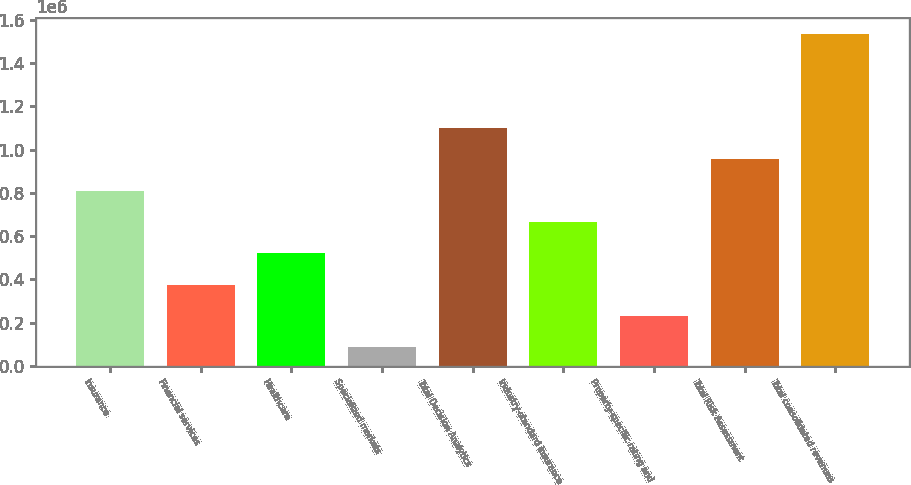Convert chart to OTSL. <chart><loc_0><loc_0><loc_500><loc_500><bar_chart><fcel>Insurance<fcel>Financial services<fcel>Healthcare<fcel>Specialized markets<fcel>Total Decision Analytics<fcel>Industry-standard insurance<fcel>Property-specific rating and<fcel>Total Risk Assessment<fcel>Total consolidated revenues<nl><fcel>809842<fcel>375155<fcel>520051<fcel>85364<fcel>1.09963e+06<fcel>664946<fcel>230260<fcel>954738<fcel>1.53432e+06<nl></chart> 